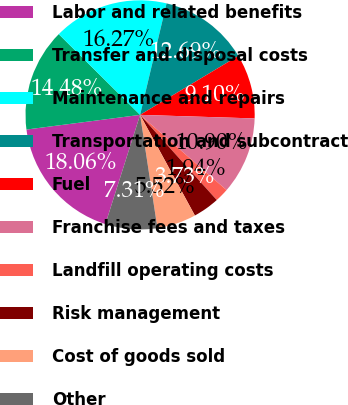Convert chart to OTSL. <chart><loc_0><loc_0><loc_500><loc_500><pie_chart><fcel>Labor and related benefits<fcel>Transfer and disposal costs<fcel>Maintenance and repairs<fcel>Transportation and subcontract<fcel>Fuel<fcel>Franchise fees and taxes<fcel>Landfill operating costs<fcel>Risk management<fcel>Cost of goods sold<fcel>Other<nl><fcel>18.06%<fcel>14.48%<fcel>16.27%<fcel>12.69%<fcel>9.1%<fcel>10.9%<fcel>1.94%<fcel>3.73%<fcel>5.52%<fcel>7.31%<nl></chart> 